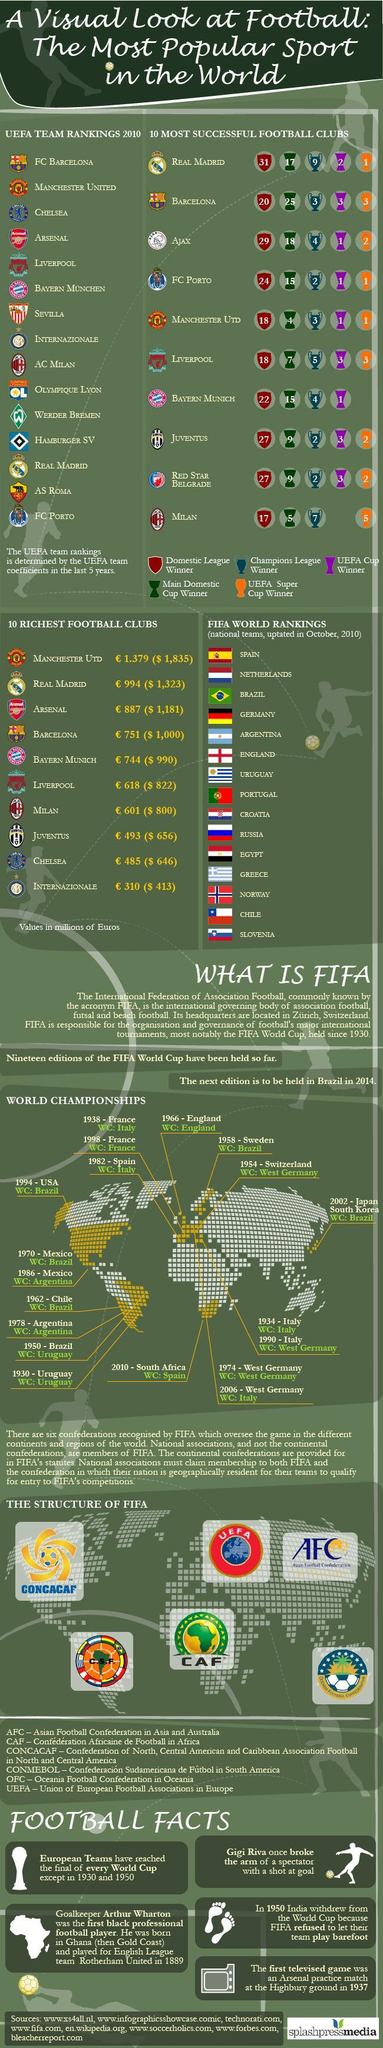Which are the three richest football clubs from bottom?
Answer the question with a short phrase. INTERNAZIONALE, CHELSEA, JUVENTUS How many country flags are shown? 15 